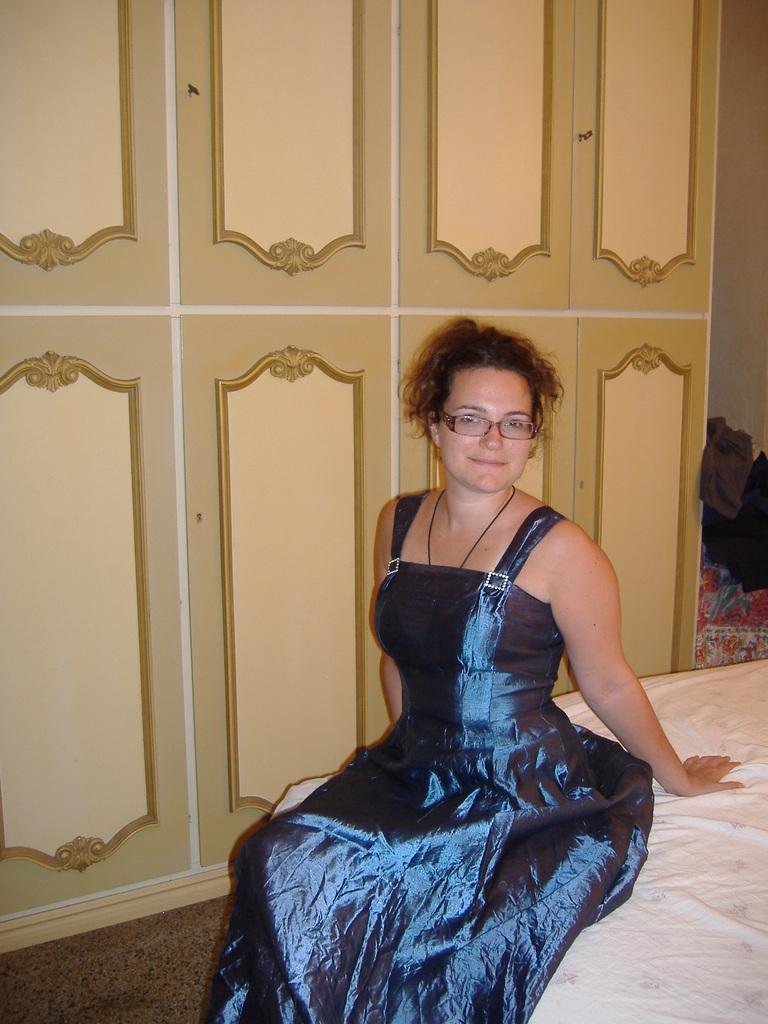In one or two sentences, can you explain what this image depicts? In this picture we can see a woman wore a spectacle and sitting on a bed and smiling and in the background we can see cupboards, clothes. 